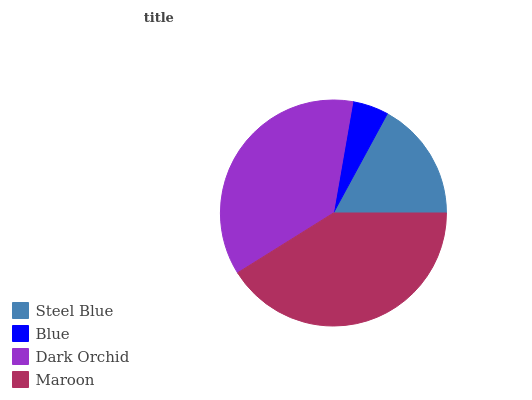Is Blue the minimum?
Answer yes or no. Yes. Is Maroon the maximum?
Answer yes or no. Yes. Is Dark Orchid the minimum?
Answer yes or no. No. Is Dark Orchid the maximum?
Answer yes or no. No. Is Dark Orchid greater than Blue?
Answer yes or no. Yes. Is Blue less than Dark Orchid?
Answer yes or no. Yes. Is Blue greater than Dark Orchid?
Answer yes or no. No. Is Dark Orchid less than Blue?
Answer yes or no. No. Is Dark Orchid the high median?
Answer yes or no. Yes. Is Steel Blue the low median?
Answer yes or no. Yes. Is Maroon the high median?
Answer yes or no. No. Is Dark Orchid the low median?
Answer yes or no. No. 